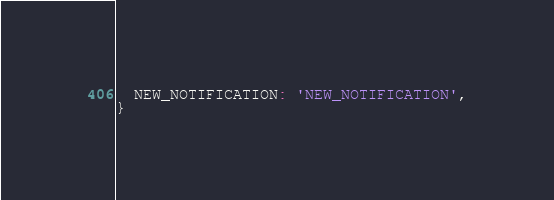Convert code to text. <code><loc_0><loc_0><loc_500><loc_500><_JavaScript_>  NEW_NOTIFICATION: 'NEW_NOTIFICATION',
}
</code> 